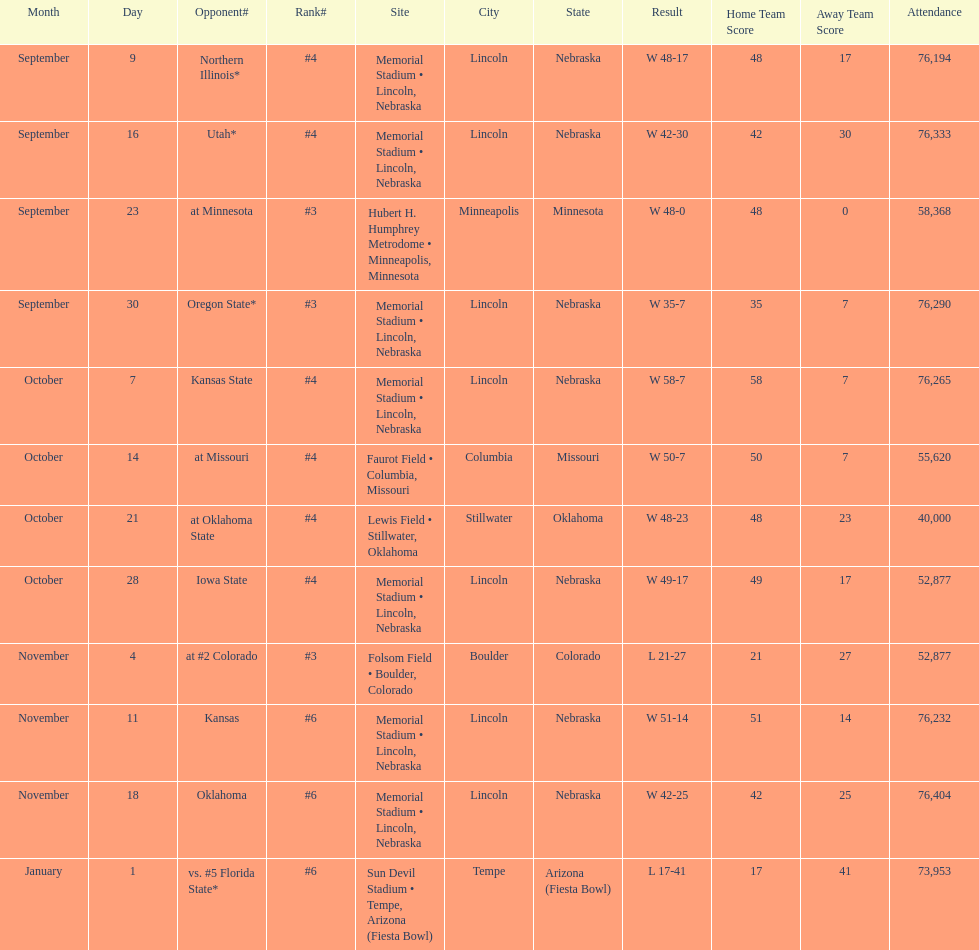When is the first game? September 9. 